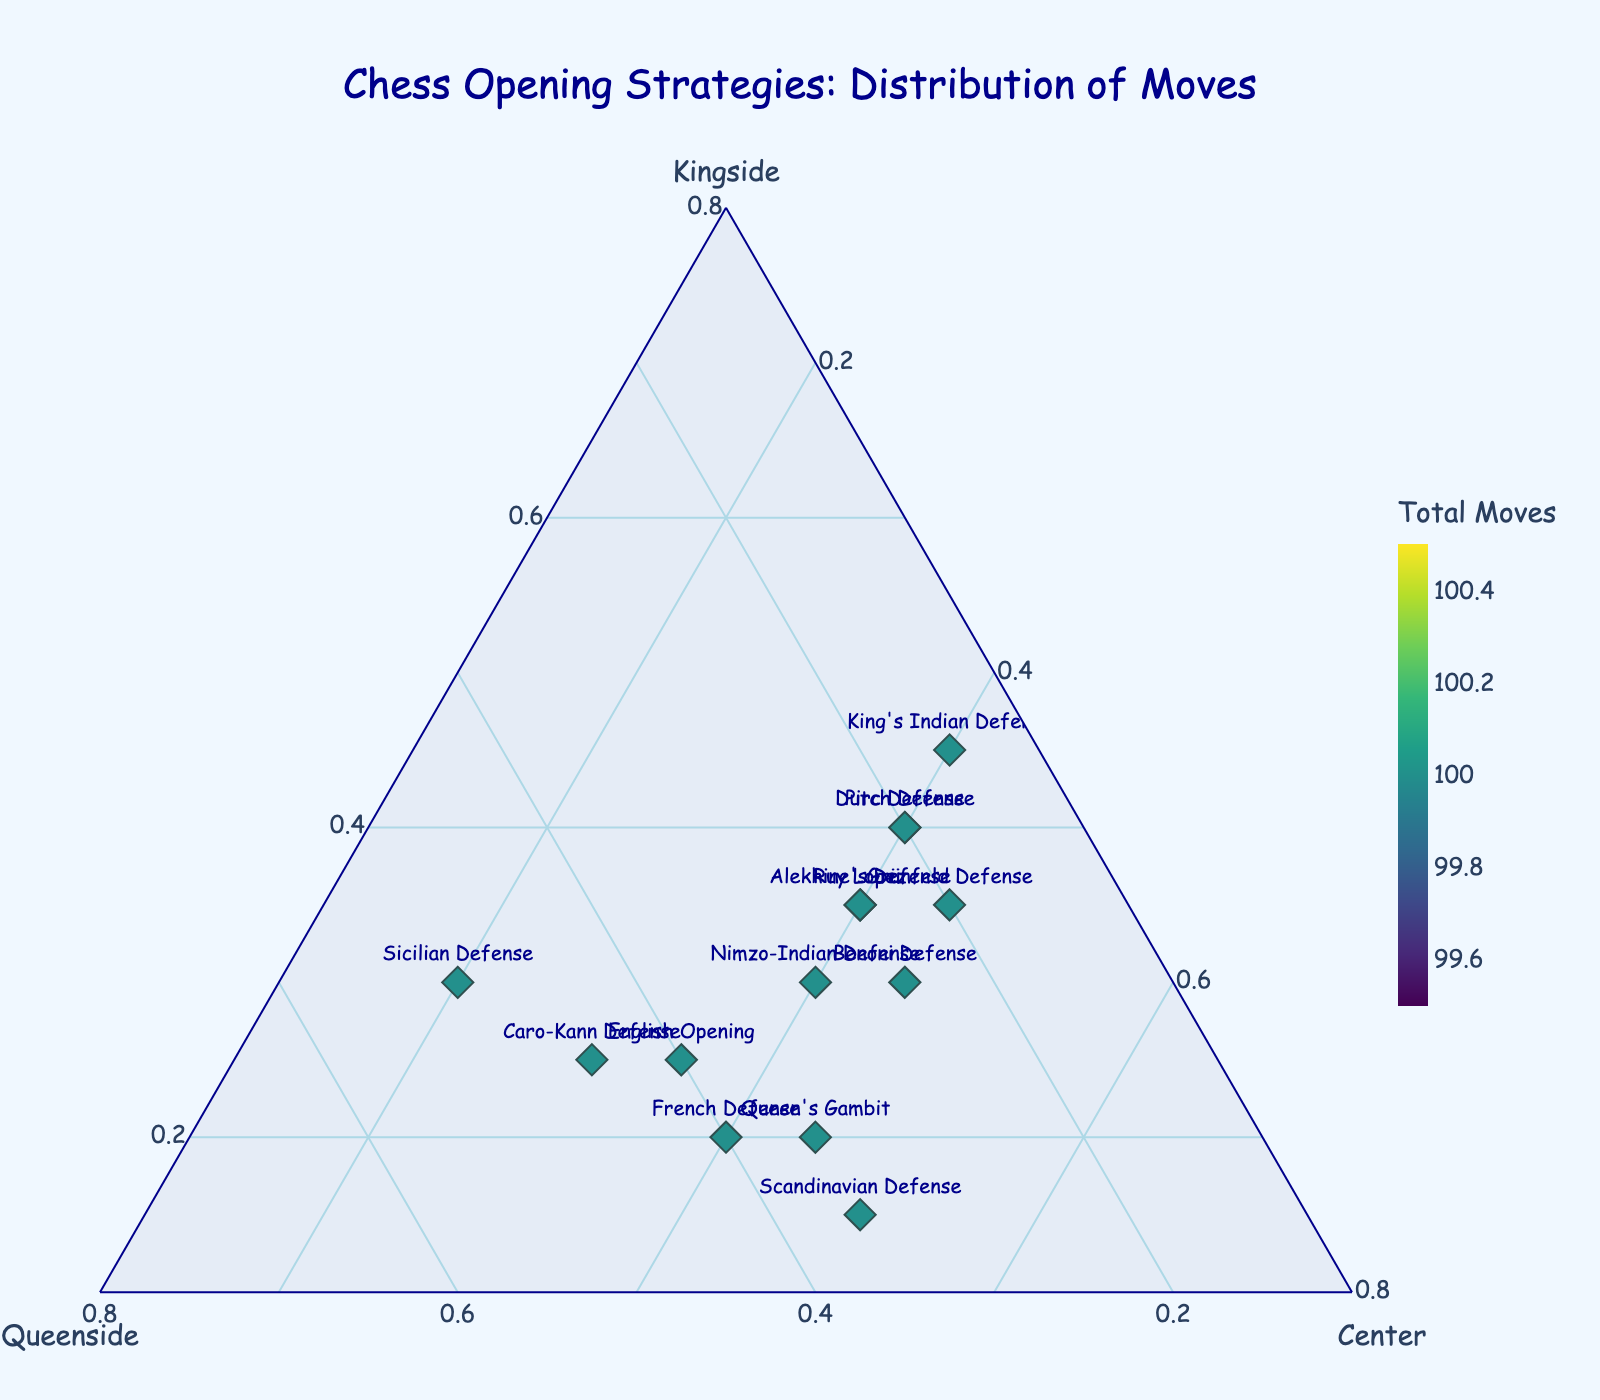What is the title of the plot? The title of the plot is prominently displayed at the top. It reads "Chess Opening Strategies: Distribution of Moves."
Answer: Chess Opening Strategies: Distribution of Moves Which opening focuses the most on center moves? By inspecting the axis labeled 'Center', we can see which data point is closest to the corresponding axis end. The Scandinavian Defense has the highest value at this position.
Answer: Scandinavian Defense How many openings have a kingside focus of more than 35%? Check each data point along the 'Kingside' axis to see if its marker is above 0.35. The openings include King's Indian Defense, Ruy Lopez, Pirc Defense, Dutch Defense, Alekhine's Defense, and Grünfeld Defense. That makes a total of 6 openings.
Answer: 6 Which two openings have equal distributions for all three types of moves? Look for points where Kingside, Queenside, and Center are all equal. None of the data points lie exactly on the bisectors of the ternary plot, so there are no openings with an equal distribution for all three types of moves.
Answer: None Which opening has the smallest proportion on the Queenside axis? Compare the points on the 'Queenside' axis and find the lowest normalized value. The King's Indian Defense has the smallest proportion on the Queenside axis at 15%.
Answer: King’s Indian Defense Which opening has the highest total number of moves? The color gradient indicates the total number of moves, with brighter colors representing higher totals. The Scandinavian Defense appears to have the brightest color, indicating the highest total number of moves.
Answer: Scandinavian Defense Are there any openings that have a similar distribution between Kingside and Center moves but differ in Queenside moves? By comparing positions of markers on the 'Kingside' and 'Center' axes, and then looking at their 'Queenside' distribution, we see that Dutch Defense and Pirc Defense both have Kansaside and Center proportions around 40%, but Dutch Defense has a Queenside value of 20% and Pirc Defense at 20%, indicating similarity and slight difference.
Answer: Dutch Defense and Pirc Defense 